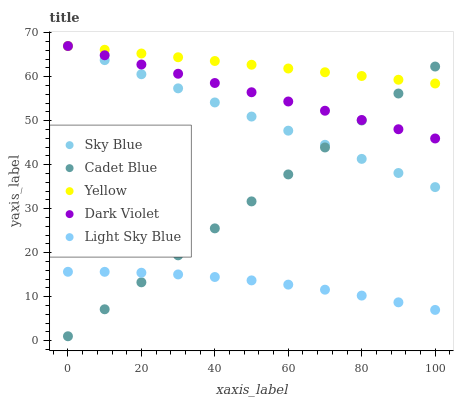Does Light Sky Blue have the minimum area under the curve?
Answer yes or no. Yes. Does Yellow have the maximum area under the curve?
Answer yes or no. Yes. Does Cadet Blue have the minimum area under the curve?
Answer yes or no. No. Does Cadet Blue have the maximum area under the curve?
Answer yes or no. No. Is Sky Blue the smoothest?
Answer yes or no. Yes. Is Light Sky Blue the roughest?
Answer yes or no. Yes. Is Cadet Blue the smoothest?
Answer yes or no. No. Is Cadet Blue the roughest?
Answer yes or no. No. Does Cadet Blue have the lowest value?
Answer yes or no. Yes. Does Dark Violet have the lowest value?
Answer yes or no. No. Does Yellow have the highest value?
Answer yes or no. Yes. Does Cadet Blue have the highest value?
Answer yes or no. No. Is Light Sky Blue less than Sky Blue?
Answer yes or no. Yes. Is Yellow greater than Light Sky Blue?
Answer yes or no. Yes. Does Dark Violet intersect Cadet Blue?
Answer yes or no. Yes. Is Dark Violet less than Cadet Blue?
Answer yes or no. No. Is Dark Violet greater than Cadet Blue?
Answer yes or no. No. Does Light Sky Blue intersect Sky Blue?
Answer yes or no. No. 